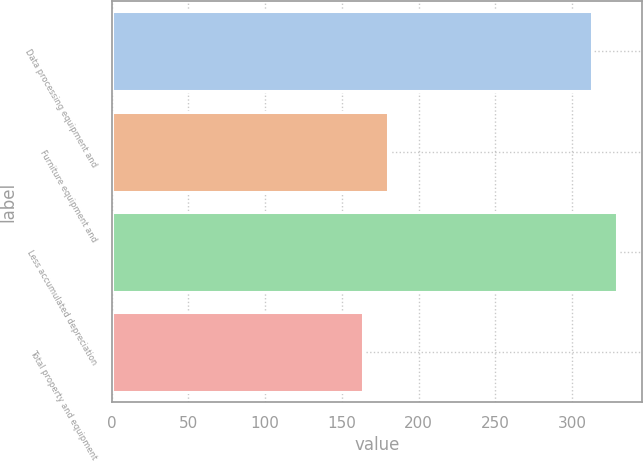<chart> <loc_0><loc_0><loc_500><loc_500><bar_chart><fcel>Data processing equipment and<fcel>Furniture equipment and<fcel>Less accumulated depreciation<fcel>Total property and equipment<nl><fcel>313<fcel>180.3<fcel>329.3<fcel>164<nl></chart> 